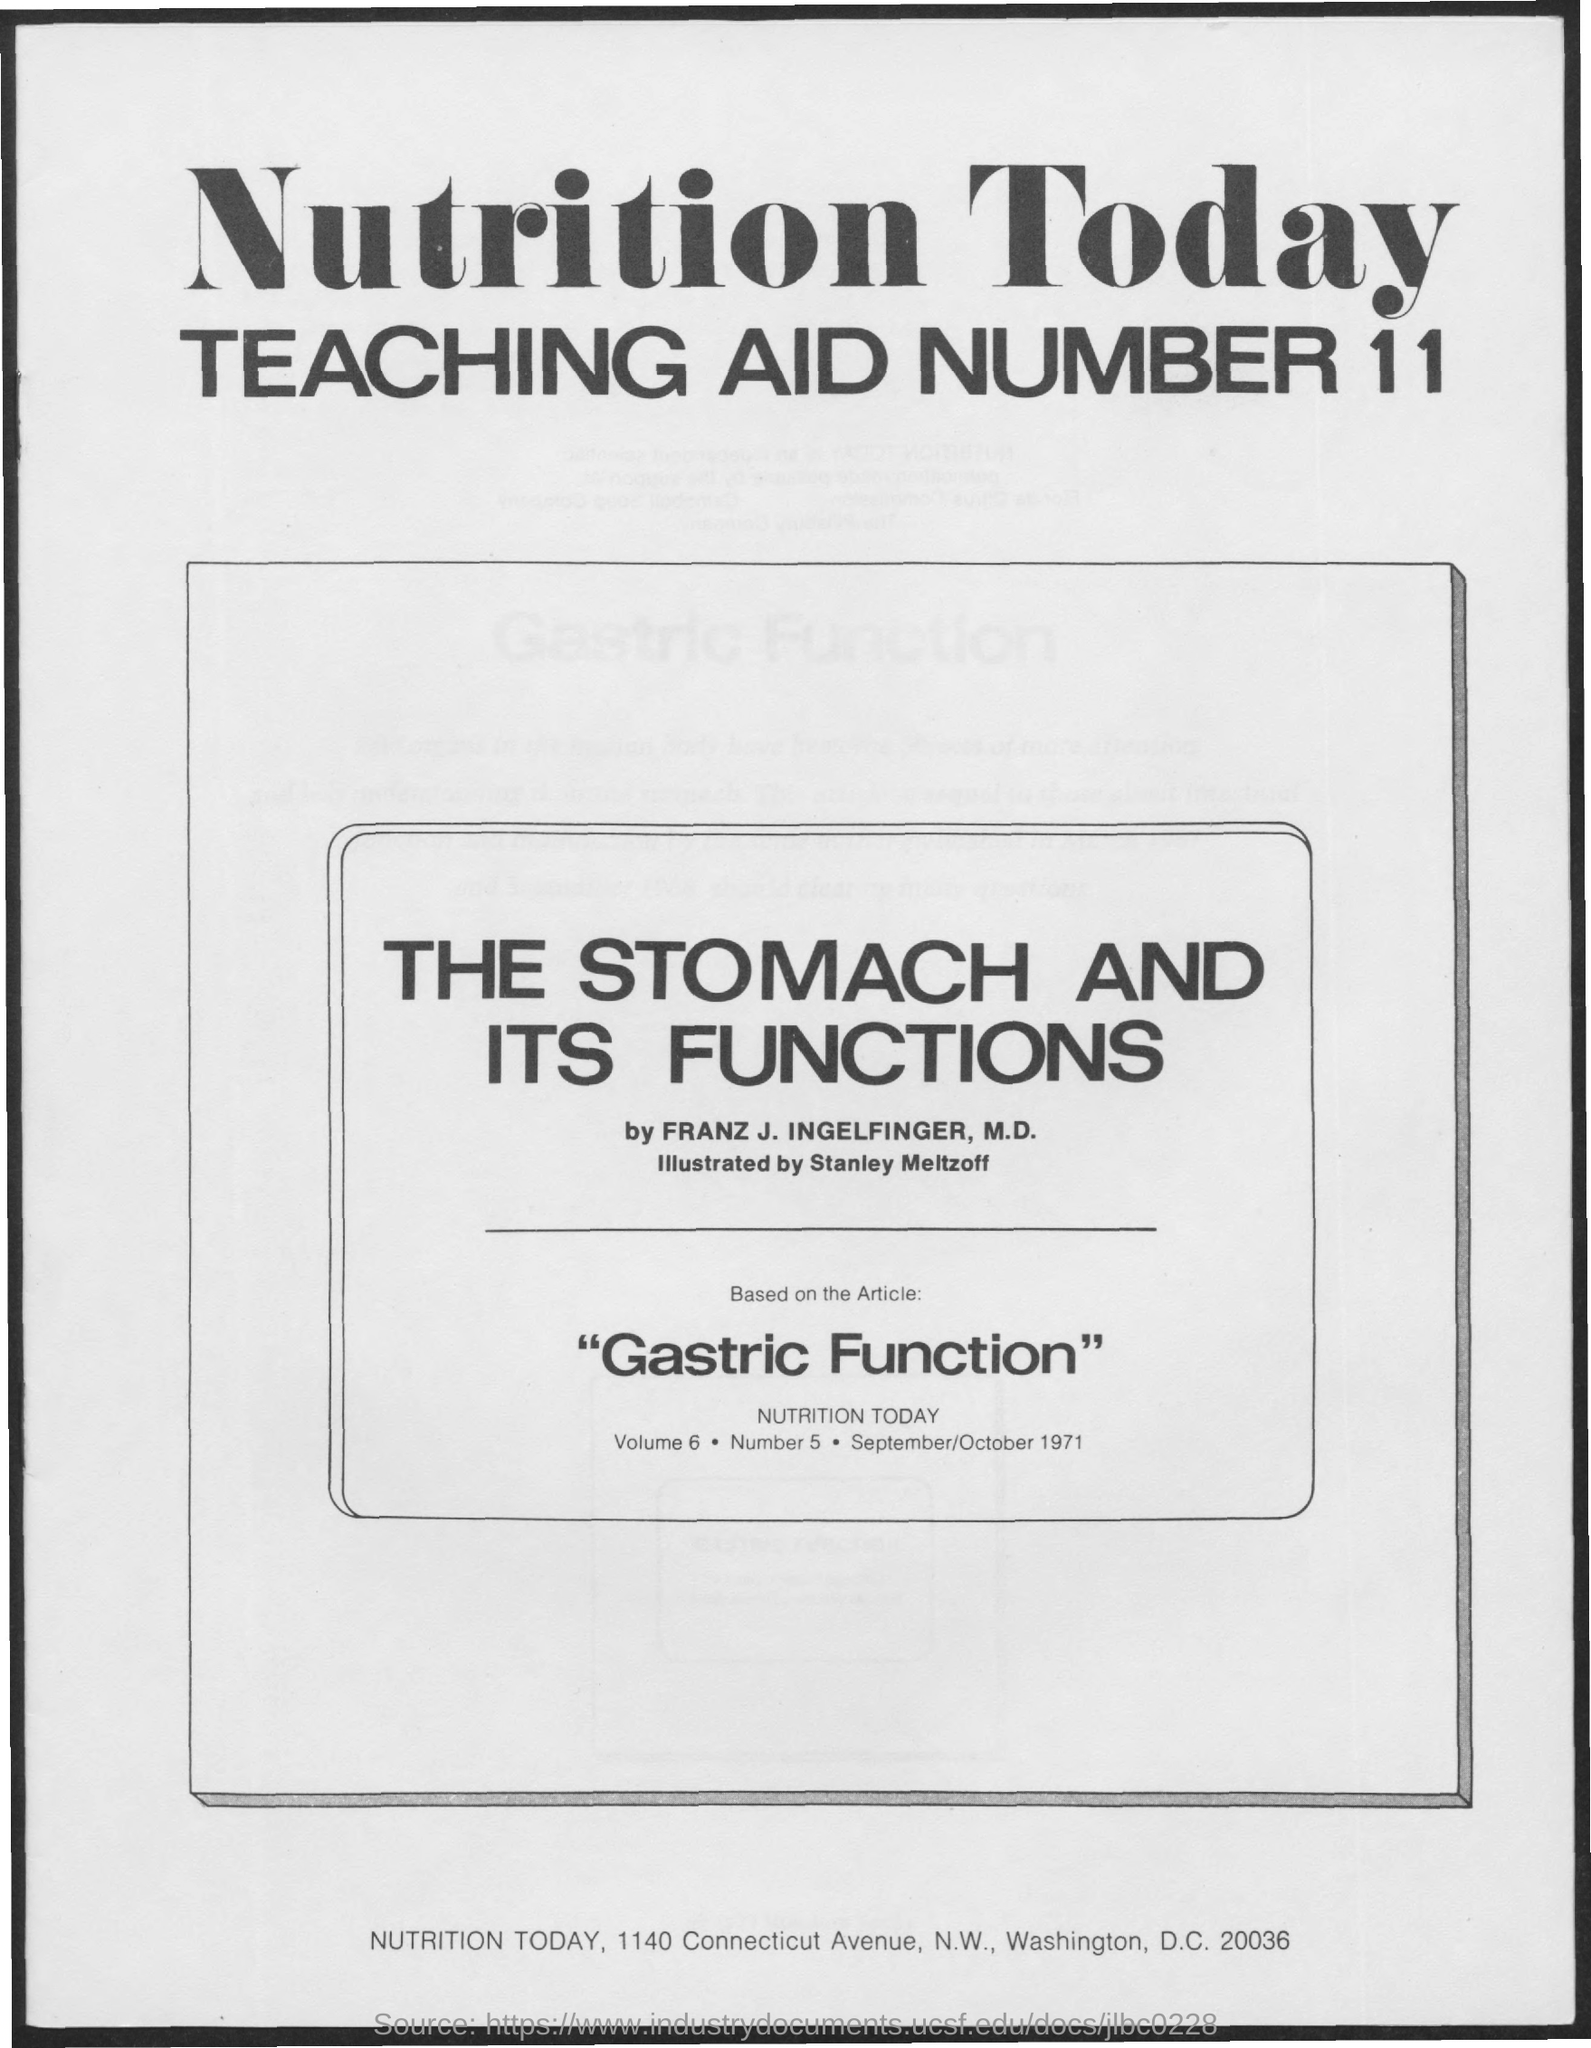What is the teaching aid number mentioned in the given page ?
Your answer should be compact. 11. What is the title of teaching aid number 11 as mentioned in the given page ?
Your answer should be very brief. The stomach and its functions. Based on which article the teaching aid was taken ?
Offer a very short reply. "Gastric Function". 